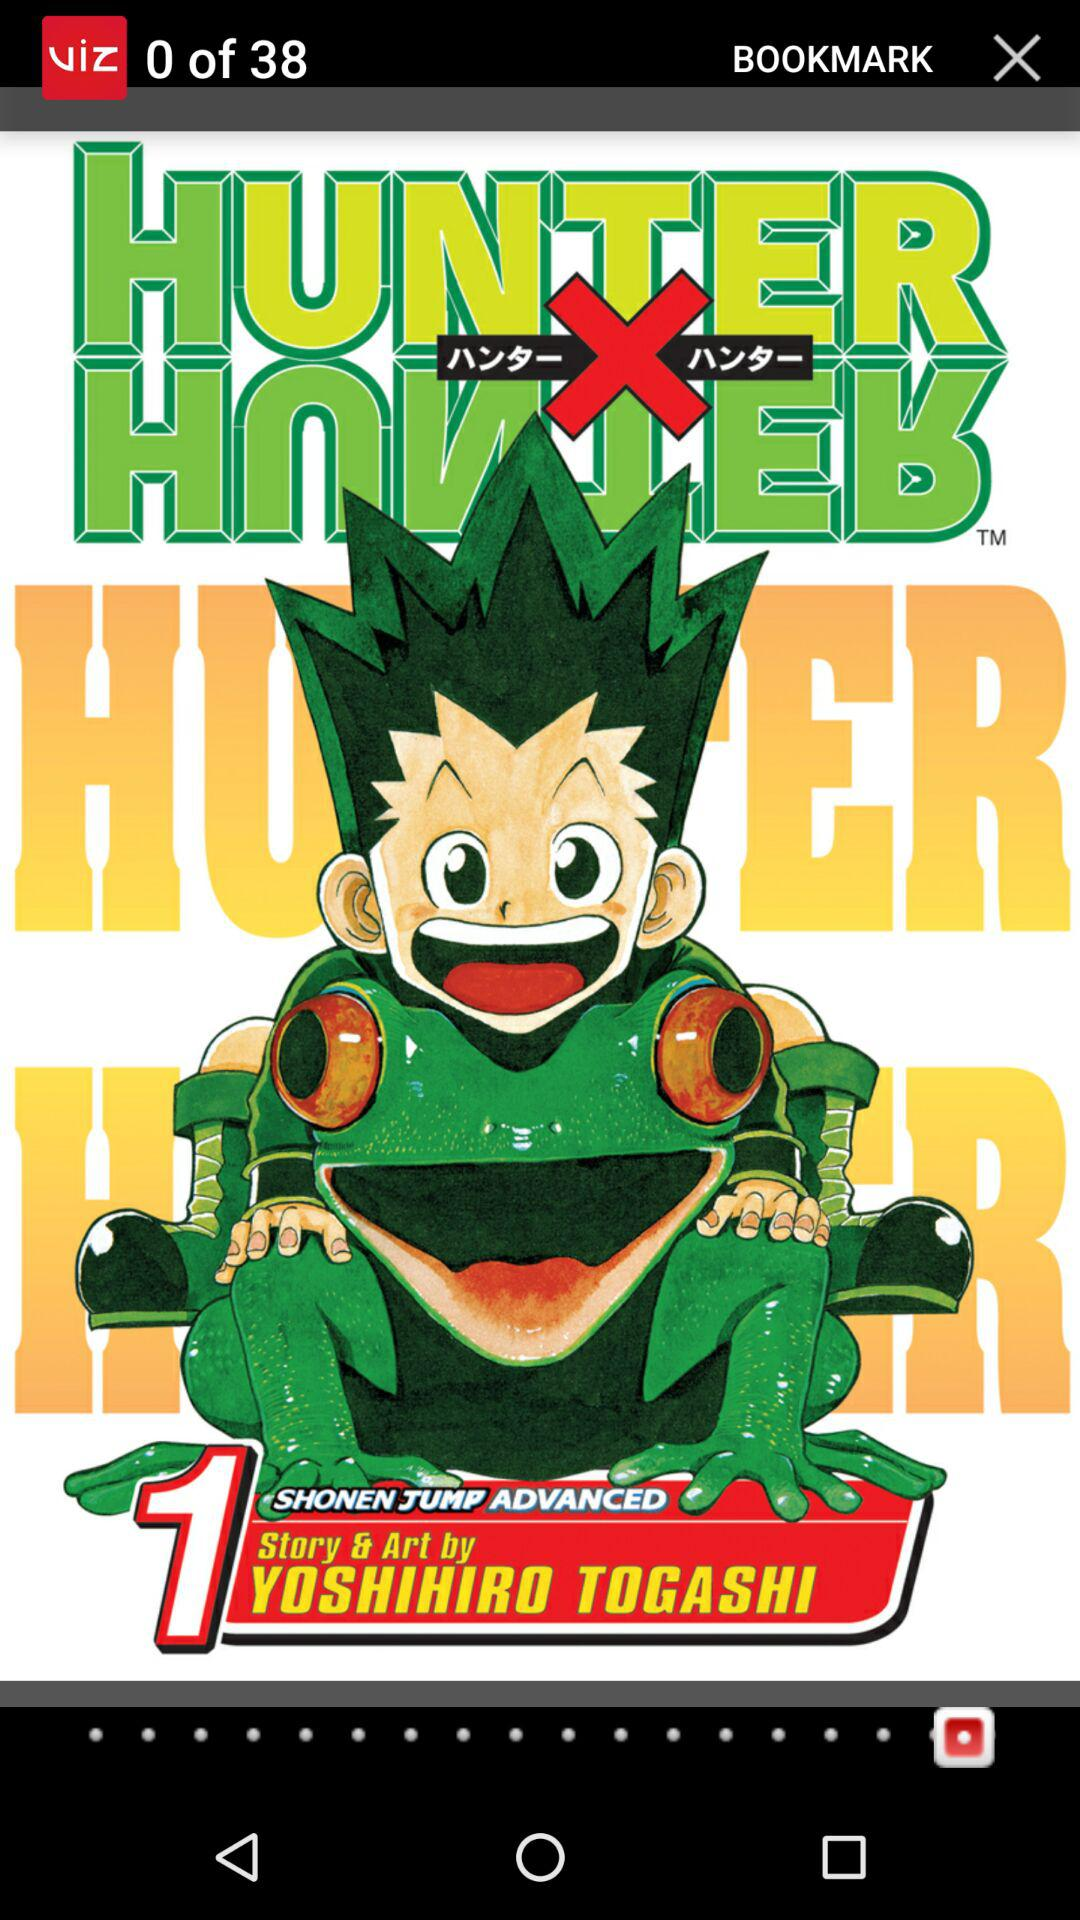What is the name of the application? The name of the application is "VIZ Manga". 